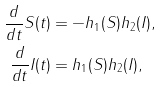Convert formula to latex. <formula><loc_0><loc_0><loc_500><loc_500>\frac { d } { d t } S ( t ) & = - h _ { 1 } ( S ) h _ { 2 } ( I ) , \\ \frac { d } { d t } I ( t ) & = h _ { 1 } ( S ) h _ { 2 } ( I ) ,</formula> 